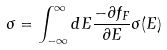Convert formula to latex. <formula><loc_0><loc_0><loc_500><loc_500>\sigma = \int _ { - \infty } ^ { \infty } d E \frac { - \partial f _ { F } } { \partial E } \sigma ( E )</formula> 